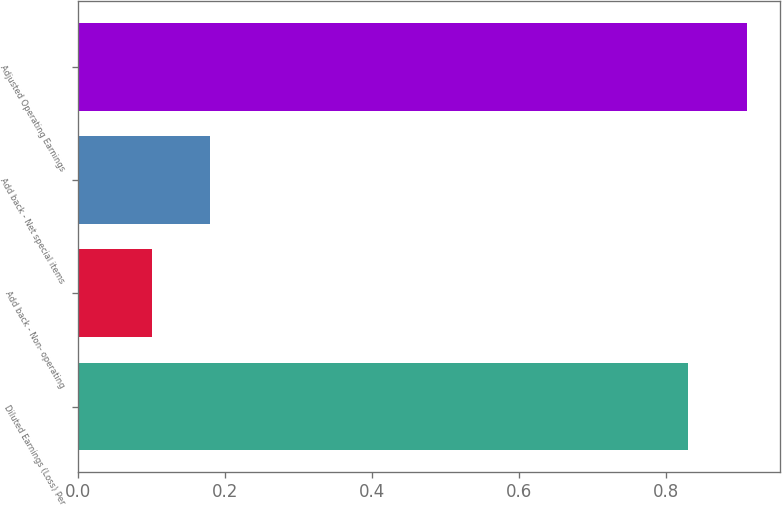Convert chart to OTSL. <chart><loc_0><loc_0><loc_500><loc_500><bar_chart><fcel>Diluted Earnings (Loss) Per<fcel>Add back - Non- operating<fcel>Add back - Net special items<fcel>Adjusted Operating Earnings<nl><fcel>0.83<fcel>0.1<fcel>0.18<fcel>0.91<nl></chart> 